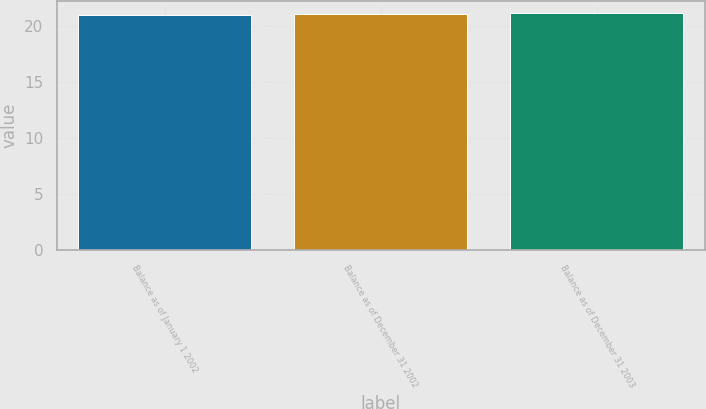<chart> <loc_0><loc_0><loc_500><loc_500><bar_chart><fcel>Balance as of January 1 2002<fcel>Balance as of December 31 2002<fcel>Balance as of December 31 2003<nl><fcel>21<fcel>21.1<fcel>21.2<nl></chart> 